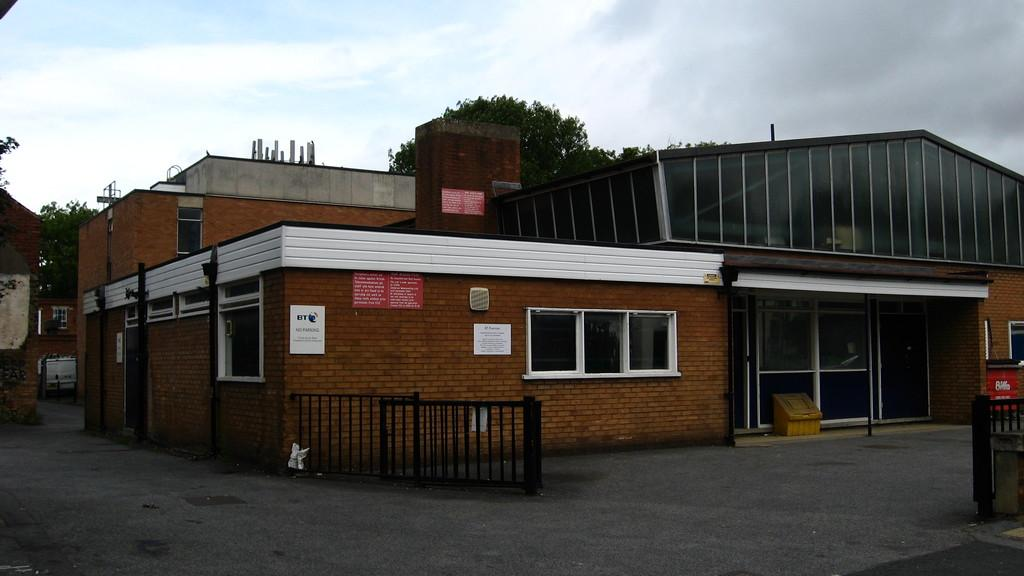What type of structure is visible in the image? There is a house in the image. What can be seen in the middle of the image? There are trees in the middle of the image. What is visible at the top of the image? The sky is visible at the top of the image. Can you see any exposed flesh in the image? There is no exposed flesh present in the image. What type of horn is visible on the house in the image? There is no horn present on the house in the image. 